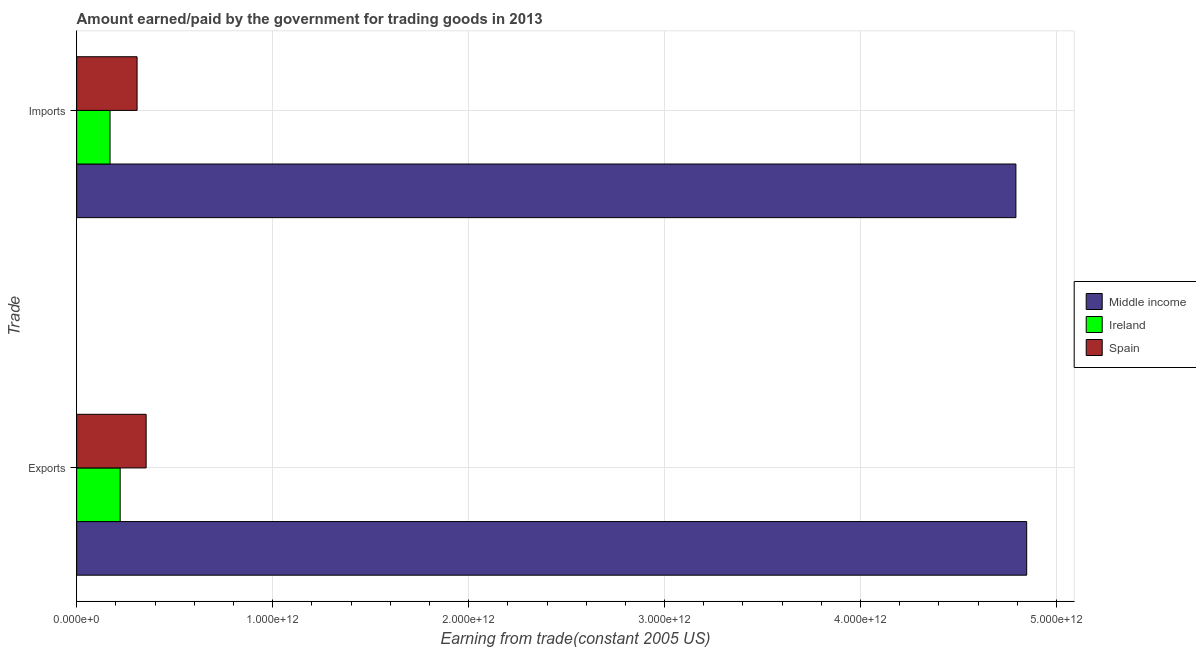Are the number of bars per tick equal to the number of legend labels?
Keep it short and to the point. Yes. Are the number of bars on each tick of the Y-axis equal?
Your answer should be compact. Yes. How many bars are there on the 1st tick from the top?
Your answer should be compact. 3. How many bars are there on the 1st tick from the bottom?
Offer a very short reply. 3. What is the label of the 1st group of bars from the top?
Your response must be concise. Imports. What is the amount paid for imports in Ireland?
Give a very brief answer. 1.70e+11. Across all countries, what is the maximum amount earned from exports?
Give a very brief answer. 4.85e+12. Across all countries, what is the minimum amount earned from exports?
Your response must be concise. 2.22e+11. In which country was the amount earned from exports minimum?
Keep it short and to the point. Ireland. What is the total amount paid for imports in the graph?
Keep it short and to the point. 5.27e+12. What is the difference between the amount paid for imports in Ireland and that in Middle income?
Provide a succinct answer. -4.62e+12. What is the difference between the amount earned from exports in Ireland and the amount paid for imports in Spain?
Provide a short and direct response. -8.63e+1. What is the average amount paid for imports per country?
Offer a very short reply. 1.76e+12. What is the difference between the amount earned from exports and amount paid for imports in Middle income?
Provide a succinct answer. 5.51e+1. What is the ratio of the amount paid for imports in Middle income to that in Ireland?
Give a very brief answer. 28.13. In how many countries, is the amount paid for imports greater than the average amount paid for imports taken over all countries?
Your response must be concise. 1. What does the 3rd bar from the top in Imports represents?
Offer a terse response. Middle income. What does the 2nd bar from the bottom in Imports represents?
Offer a very short reply. Ireland. How many bars are there?
Offer a terse response. 6. Are all the bars in the graph horizontal?
Your answer should be compact. Yes. What is the difference between two consecutive major ticks on the X-axis?
Keep it short and to the point. 1.00e+12. Are the values on the major ticks of X-axis written in scientific E-notation?
Keep it short and to the point. Yes. Where does the legend appear in the graph?
Make the answer very short. Center right. How many legend labels are there?
Your answer should be very brief. 3. What is the title of the graph?
Keep it short and to the point. Amount earned/paid by the government for trading goods in 2013. What is the label or title of the X-axis?
Your response must be concise. Earning from trade(constant 2005 US). What is the label or title of the Y-axis?
Your answer should be compact. Trade. What is the Earning from trade(constant 2005 US) of Middle income in Exports?
Your response must be concise. 4.85e+12. What is the Earning from trade(constant 2005 US) in Ireland in Exports?
Provide a short and direct response. 2.22e+11. What is the Earning from trade(constant 2005 US) in Spain in Exports?
Your answer should be very brief. 3.55e+11. What is the Earning from trade(constant 2005 US) in Middle income in Imports?
Give a very brief answer. 4.79e+12. What is the Earning from trade(constant 2005 US) in Ireland in Imports?
Provide a short and direct response. 1.70e+11. What is the Earning from trade(constant 2005 US) of Spain in Imports?
Offer a terse response. 3.08e+11. Across all Trade, what is the maximum Earning from trade(constant 2005 US) in Middle income?
Ensure brevity in your answer.  4.85e+12. Across all Trade, what is the maximum Earning from trade(constant 2005 US) of Ireland?
Ensure brevity in your answer.  2.22e+11. Across all Trade, what is the maximum Earning from trade(constant 2005 US) in Spain?
Your response must be concise. 3.55e+11. Across all Trade, what is the minimum Earning from trade(constant 2005 US) in Middle income?
Make the answer very short. 4.79e+12. Across all Trade, what is the minimum Earning from trade(constant 2005 US) of Ireland?
Offer a terse response. 1.70e+11. Across all Trade, what is the minimum Earning from trade(constant 2005 US) of Spain?
Your answer should be very brief. 3.08e+11. What is the total Earning from trade(constant 2005 US) of Middle income in the graph?
Your answer should be very brief. 9.64e+12. What is the total Earning from trade(constant 2005 US) in Ireland in the graph?
Your answer should be compact. 3.92e+11. What is the total Earning from trade(constant 2005 US) in Spain in the graph?
Keep it short and to the point. 6.63e+11. What is the difference between the Earning from trade(constant 2005 US) of Middle income in Exports and that in Imports?
Make the answer very short. 5.51e+1. What is the difference between the Earning from trade(constant 2005 US) of Ireland in Exports and that in Imports?
Offer a terse response. 5.17e+1. What is the difference between the Earning from trade(constant 2005 US) in Spain in Exports and that in Imports?
Your answer should be compact. 4.63e+1. What is the difference between the Earning from trade(constant 2005 US) of Middle income in Exports and the Earning from trade(constant 2005 US) of Ireland in Imports?
Provide a succinct answer. 4.68e+12. What is the difference between the Earning from trade(constant 2005 US) of Middle income in Exports and the Earning from trade(constant 2005 US) of Spain in Imports?
Your response must be concise. 4.54e+12. What is the difference between the Earning from trade(constant 2005 US) of Ireland in Exports and the Earning from trade(constant 2005 US) of Spain in Imports?
Provide a short and direct response. -8.63e+1. What is the average Earning from trade(constant 2005 US) in Middle income per Trade?
Provide a short and direct response. 4.82e+12. What is the average Earning from trade(constant 2005 US) in Ireland per Trade?
Your answer should be compact. 1.96e+11. What is the average Earning from trade(constant 2005 US) of Spain per Trade?
Offer a very short reply. 3.31e+11. What is the difference between the Earning from trade(constant 2005 US) in Middle income and Earning from trade(constant 2005 US) in Ireland in Exports?
Offer a terse response. 4.63e+12. What is the difference between the Earning from trade(constant 2005 US) in Middle income and Earning from trade(constant 2005 US) in Spain in Exports?
Ensure brevity in your answer.  4.49e+12. What is the difference between the Earning from trade(constant 2005 US) of Ireland and Earning from trade(constant 2005 US) of Spain in Exports?
Keep it short and to the point. -1.33e+11. What is the difference between the Earning from trade(constant 2005 US) of Middle income and Earning from trade(constant 2005 US) of Ireland in Imports?
Provide a succinct answer. 4.62e+12. What is the difference between the Earning from trade(constant 2005 US) in Middle income and Earning from trade(constant 2005 US) in Spain in Imports?
Your response must be concise. 4.48e+12. What is the difference between the Earning from trade(constant 2005 US) of Ireland and Earning from trade(constant 2005 US) of Spain in Imports?
Provide a short and direct response. -1.38e+11. What is the ratio of the Earning from trade(constant 2005 US) in Middle income in Exports to that in Imports?
Your answer should be compact. 1.01. What is the ratio of the Earning from trade(constant 2005 US) in Ireland in Exports to that in Imports?
Provide a short and direct response. 1.3. What is the ratio of the Earning from trade(constant 2005 US) in Spain in Exports to that in Imports?
Make the answer very short. 1.15. What is the difference between the highest and the second highest Earning from trade(constant 2005 US) of Middle income?
Your answer should be compact. 5.51e+1. What is the difference between the highest and the second highest Earning from trade(constant 2005 US) of Ireland?
Your response must be concise. 5.17e+1. What is the difference between the highest and the second highest Earning from trade(constant 2005 US) of Spain?
Ensure brevity in your answer.  4.63e+1. What is the difference between the highest and the lowest Earning from trade(constant 2005 US) of Middle income?
Provide a short and direct response. 5.51e+1. What is the difference between the highest and the lowest Earning from trade(constant 2005 US) in Ireland?
Keep it short and to the point. 5.17e+1. What is the difference between the highest and the lowest Earning from trade(constant 2005 US) in Spain?
Provide a succinct answer. 4.63e+1. 